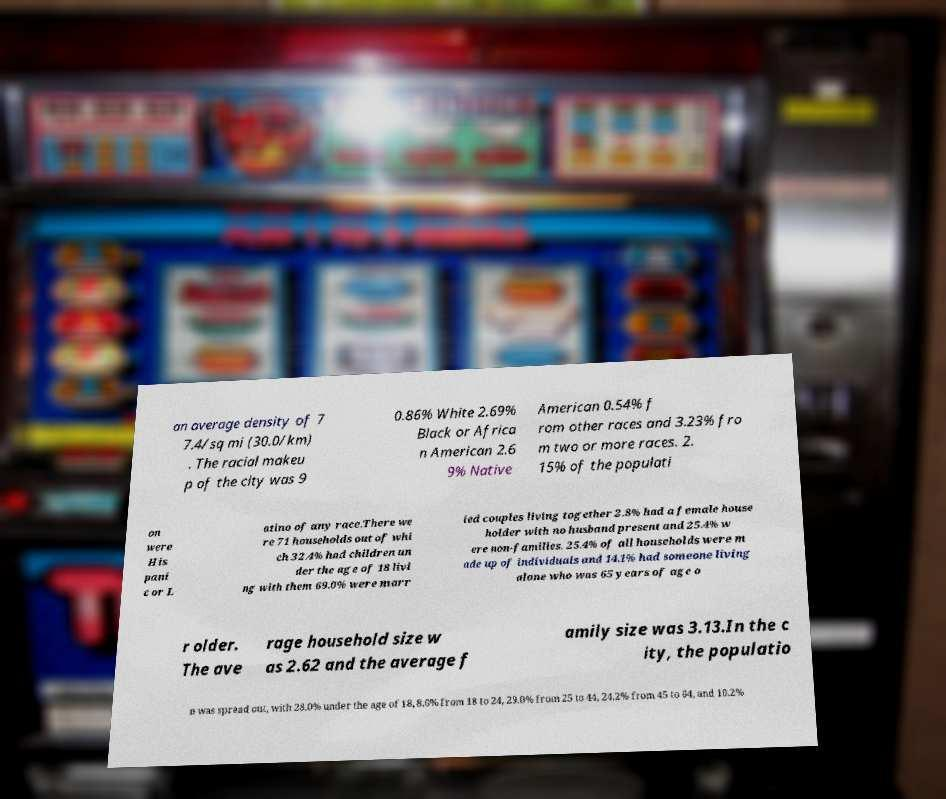Could you extract and type out the text from this image? an average density of 7 7.4/sq mi (30.0/km) . The racial makeu p of the city was 9 0.86% White 2.69% Black or Africa n American 2.6 9% Native American 0.54% f rom other races and 3.23% fro m two or more races. 2. 15% of the populati on were His pani c or L atino of any race.There we re 71 households out of whi ch 32.4% had children un der the age of 18 livi ng with them 69.0% were marr ied couples living together 2.8% had a female house holder with no husband present and 25.4% w ere non-families. 25.4% of all households were m ade up of individuals and 14.1% had someone living alone who was 65 years of age o r older. The ave rage household size w as 2.62 and the average f amily size was 3.13.In the c ity, the populatio n was spread out, with 28.0% under the age of 18, 8.6% from 18 to 24, 29.0% from 25 to 44, 24.2% from 45 to 64, and 10.2% 